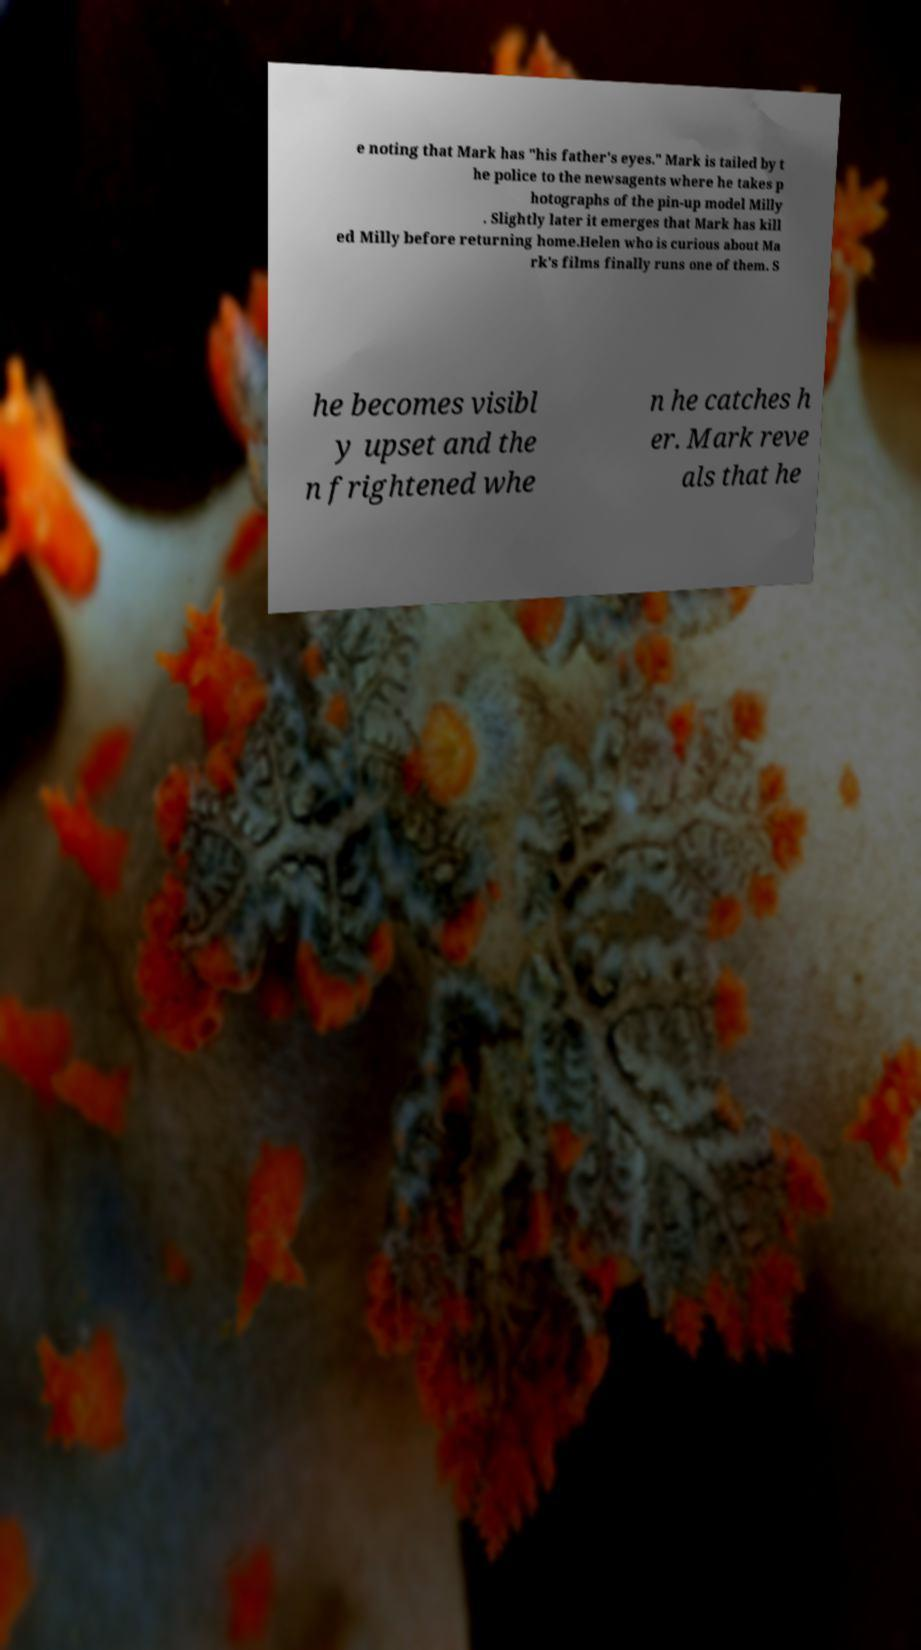There's text embedded in this image that I need extracted. Can you transcribe it verbatim? e noting that Mark has "his father's eyes." Mark is tailed by t he police to the newsagents where he takes p hotographs of the pin-up model Milly . Slightly later it emerges that Mark has kill ed Milly before returning home.Helen who is curious about Ma rk's films finally runs one of them. S he becomes visibl y upset and the n frightened whe n he catches h er. Mark reve als that he 